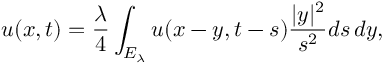<formula> <loc_0><loc_0><loc_500><loc_500>u ( x , t ) = { \frac { \lambda } { 4 } } \int _ { E _ { \lambda } } u ( x - y , t - s ) { \frac { | y | ^ { 2 } } { s ^ { 2 } } } d s \, d y ,</formula> 